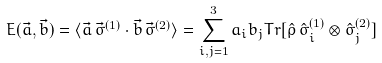<formula> <loc_0><loc_0><loc_500><loc_500>E ( \vec { a } , \vec { b } ) = \langle \vec { a } \, \vec { \sigma } ^ { ( 1 ) } \cdot \vec { b } \, \vec { \sigma } ^ { ( 2 ) } \rangle = \sum _ { i , j = 1 } ^ { 3 } a _ { i } b _ { j } T r [ \hat { \rho } \, \hat { \sigma } _ { i } ^ { ( 1 ) } \otimes \hat { \sigma } _ { j } ^ { ( 2 ) } ]</formula> 